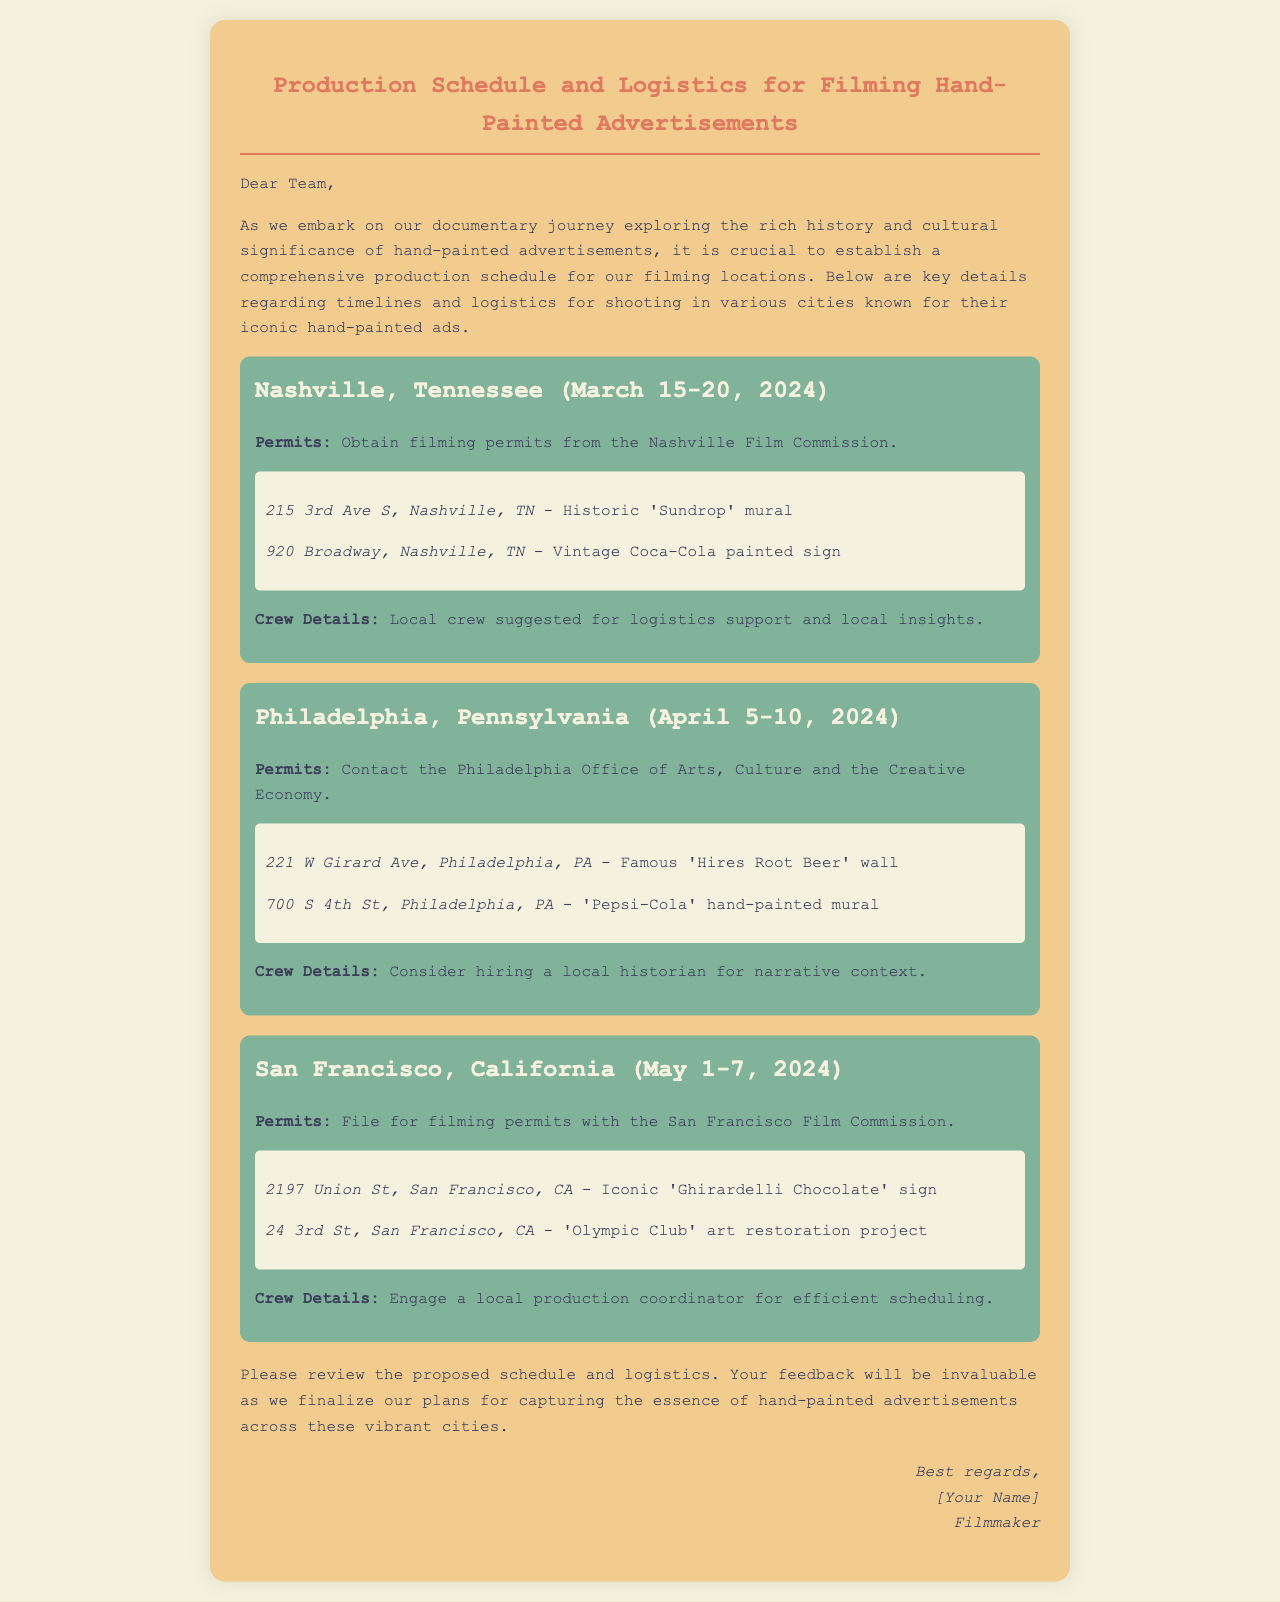What are the filming dates for Nashville? The filming dates for Nashville are mentioned specifically as March 15-20, 2024.
Answer: March 15-20, 2024 What is the first location in Philadelphia? The first location in Philadelphia is specified as 221 W Girard Ave, Philadelphia, PA - Famous 'Hires Root Beer' wall.
Answer: 221 W Girard Ave, Philadelphia, PA What type of professional is suggested for San Francisco? The document suggests engaging a local production coordinator for efficient scheduling in San Francisco.
Answer: Local production coordinator How many filming locations are mentioned in the document? The document mentions a total of three filming locations: Nashville, Philadelphia, and San Francisco.
Answer: Three What is the address of the 'Sundrop' mural? The address of the 'Sundrop' mural is provided in the Nashville section.
Answer: 215 3rd Ave S, Nashville, TN What organization should be contacted for permits in Philadelphia? The document advises contacting the Philadelphia Office of Arts, Culture and the Creative Economy for permits.
Answer: Philadelphia Office of Arts, Culture and the Creative Economy What is the proposed filming date range for San Francisco? The proposed filming date range for San Francisco is outlined as May 1-7, 2024.
Answer: May 1-7, 2024 What notable sign is located at 24 3rd St, San Francisco, CA? The document lists the 'Olympic Club' art restoration project at the specified address in San Francisco.
Answer: Olympic Club 